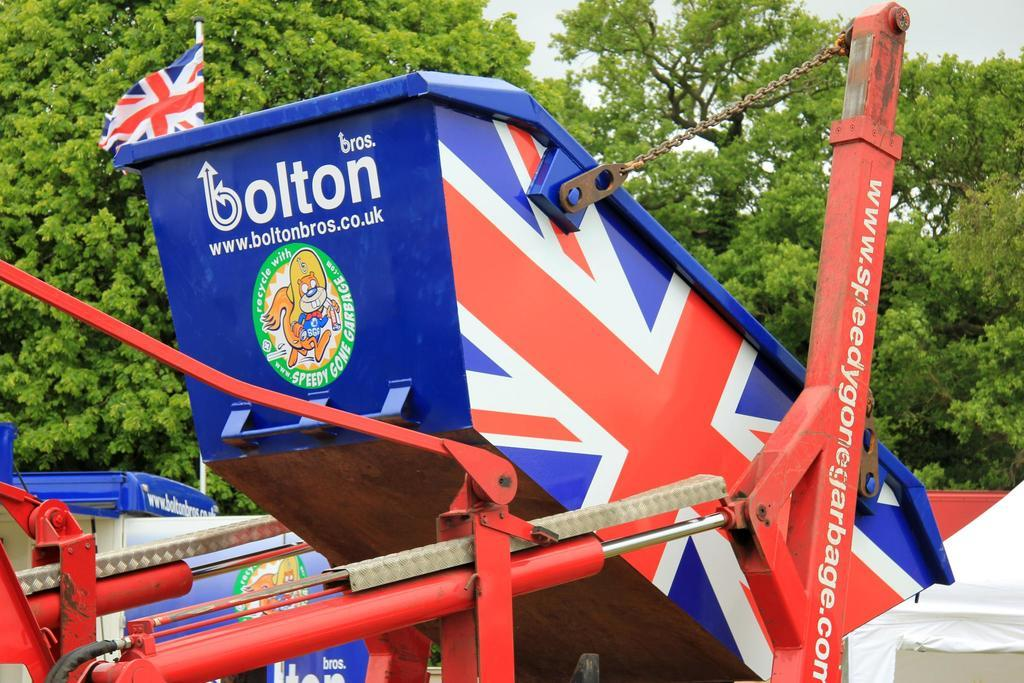What type of objects can be seen in the image? There are metal objects in the image. What can be seen in the background of the image? There are trees in the background of the image. How many zebras can be seen in the image? There are no zebras present in the image. What time of day is depicted in the image? The time of day cannot be determined from the image, as there is no information about lighting or shadows. 